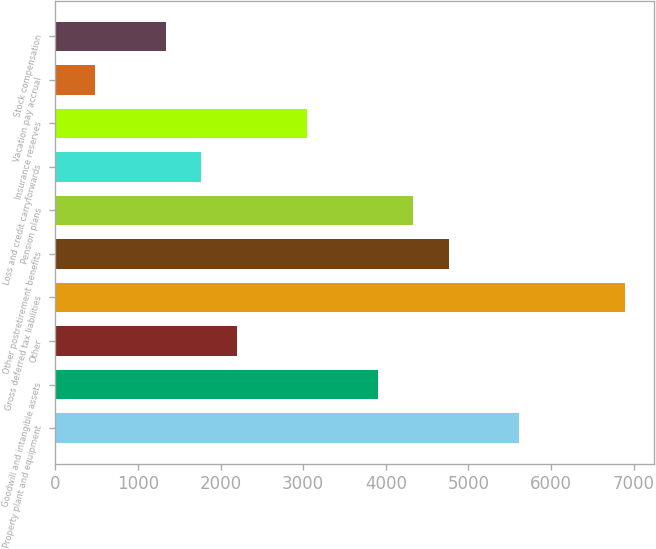Convert chart to OTSL. <chart><loc_0><loc_0><loc_500><loc_500><bar_chart><fcel>Property plant and equipment<fcel>Goodwill and intangible assets<fcel>Other<fcel>Gross deferred tax liabilities<fcel>Other postretirement benefits<fcel>Pension plans<fcel>Loss and credit carryforwards<fcel>Insurance reserves<fcel>Vacation pay accrual<fcel>Stock compensation<nl><fcel>5616.7<fcel>3905.1<fcel>2193.5<fcel>6900.4<fcel>4760.9<fcel>4333<fcel>1765.6<fcel>3049.3<fcel>481.9<fcel>1337.7<nl></chart> 